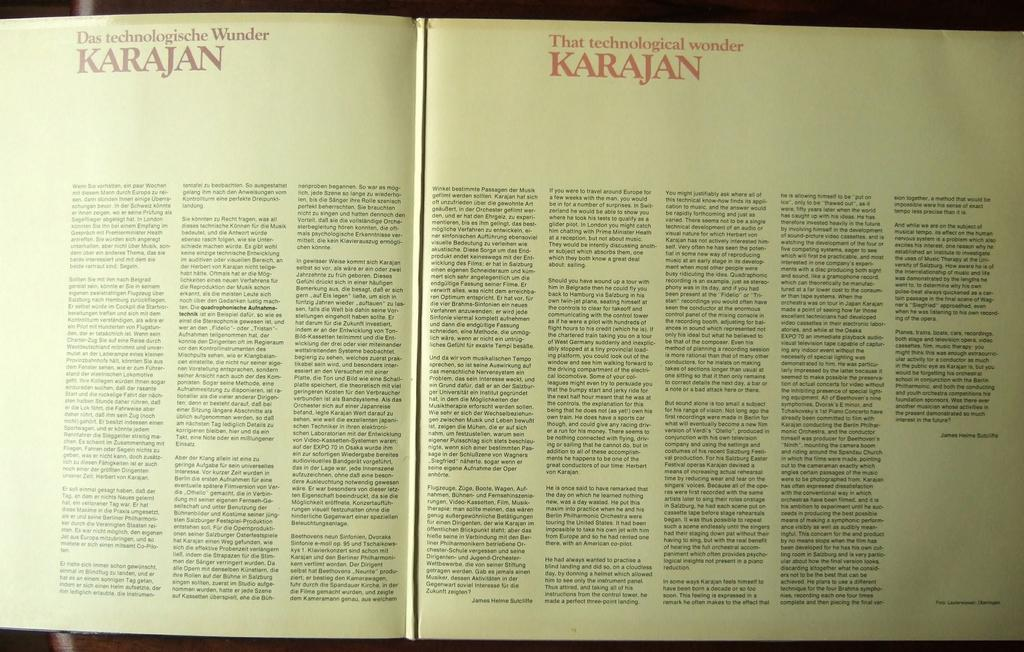<image>
Describe the image concisely. A book is open to a page with the heading Karajan. 